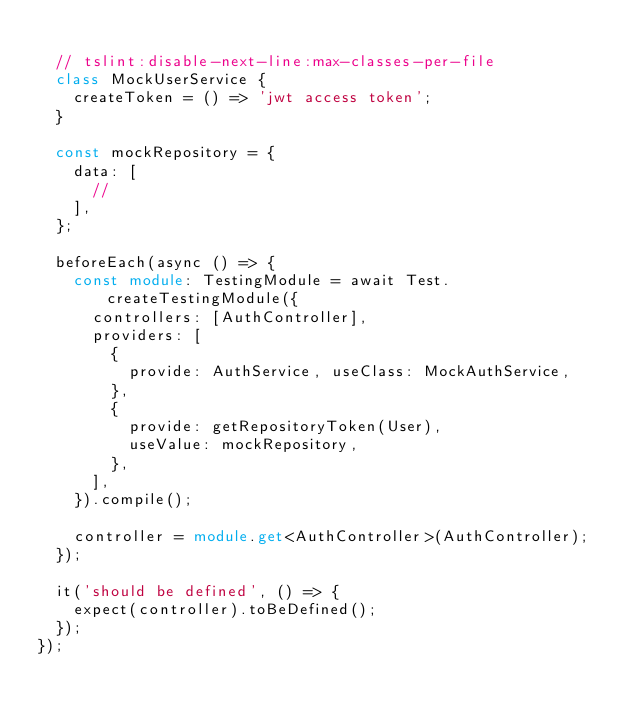<code> <loc_0><loc_0><loc_500><loc_500><_TypeScript_>
  // tslint:disable-next-line:max-classes-per-file
  class MockUserService {
    createToken = () => 'jwt access token';
  }

  const mockRepository = {
    data: [
      //
    ],
  };

  beforeEach(async () => {
    const module: TestingModule = await Test.createTestingModule({
      controllers: [AuthController],
      providers: [
        {
          provide: AuthService, useClass: MockAuthService,
        },
        {
          provide: getRepositoryToken(User),
          useValue: mockRepository,
        },
      ],
    }).compile();

    controller = module.get<AuthController>(AuthController);
  });

  it('should be defined', () => {
    expect(controller).toBeDefined();
  });
});
</code> 